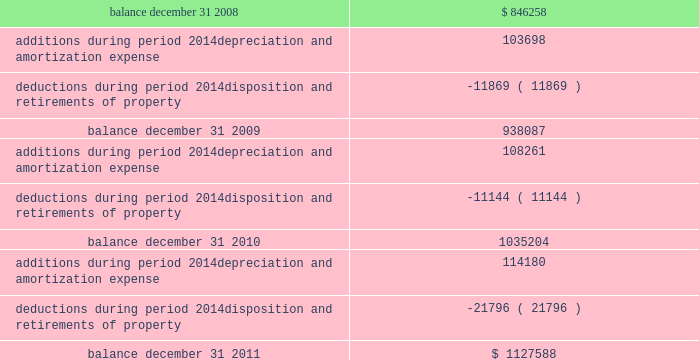Federal realty investment trust schedule iii summary of real estate and accumulated depreciation - continued three years ended december 31 , 2011 reconciliation of accumulated depreciation and amortization ( in thousands ) balance , december 31 , 2008................................................................................................................................... .
Additions during period 2014depreciation and amortization expense .................................................................... .
Deductions during period 2014disposition and retirements of property ................................................................. .
Balance , december 31 , 2009................................................................................................................................... .
Additions during period 2014depreciation and amortization expense .................................................................... .
Deductions during period 2014disposition and retirements of property ................................................................. .
Balance , december 31 , 2010................................................................................................................................... .
Additions during period 2014depreciation and amortization expense .................................................................... .
Deductions during period 2014disposition and retirements of property ................................................................. .
Balance , december 31 , 2011................................................................................................................................... .
$ 846258 103698 ( 11869 ) 938087 108261 ( 11144 ) 1035204 114180 ( 21796 ) $ 1127588 .
Federal realty investment trust schedule iii summary of real estate and accumulated depreciation - continued three years ended december 31 , 2011 reconciliation of accumulated depreciation and amortization ( in thousands ) balance , december 31 , 2008................................................................................................................................... .
Additions during period 2014depreciation and amortization expense .................................................................... .
Deductions during period 2014disposition and retirements of property ................................................................. .
Balance , december 31 , 2009................................................................................................................................... .
Additions during period 2014depreciation and amortization expense .................................................................... .
Deductions during period 2014disposition and retirements of property ................................................................. .
Balance , december 31 , 2010................................................................................................................................... .
Additions during period 2014depreciation and amortization expense .................................................................... .
Deductions during period 2014disposition and retirements of property ................................................................. .
Balance , december 31 , 2011................................................................................................................................... .
$ 846258 103698 ( 11869 ) 938087 108261 ( 11144 ) 1035204 114180 ( 21796 ) $ 1127588 .
What is the percentual growth of the depreciation and amortization expenses during 2008 and 2009? 
Rationale: it is the depreciation and amortization expenses of 2009 divided by the 2009's then turned into a percentage .
Computations: ((108261 / 103698) - 1)
Answer: 0.044. 